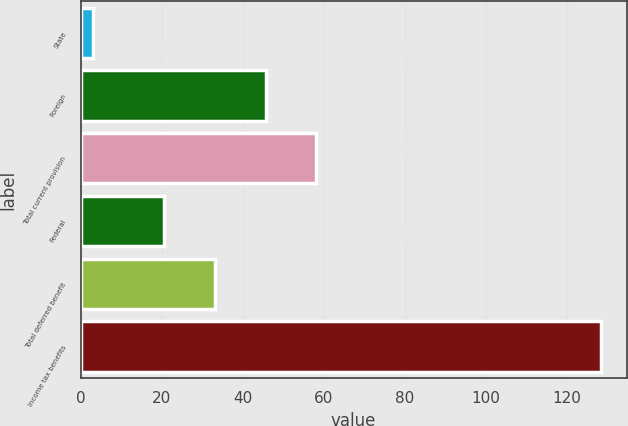<chart> <loc_0><loc_0><loc_500><loc_500><bar_chart><fcel>State<fcel>Foreign<fcel>Total current provision<fcel>Federal<fcel>Total deferred benefit<fcel>Income tax benefits<nl><fcel>3<fcel>45.66<fcel>58.19<fcel>20.6<fcel>33.13<fcel>128.3<nl></chart> 